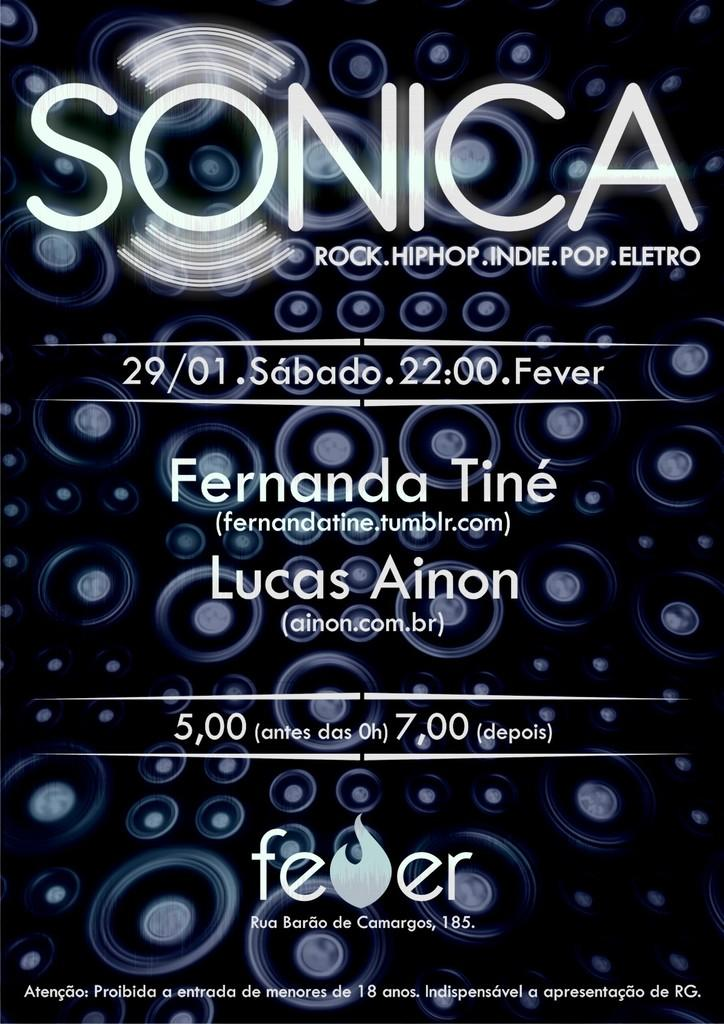<image>
Give a short and clear explanation of the subsequent image. A SONICA poster advertises an upcoming music event. 